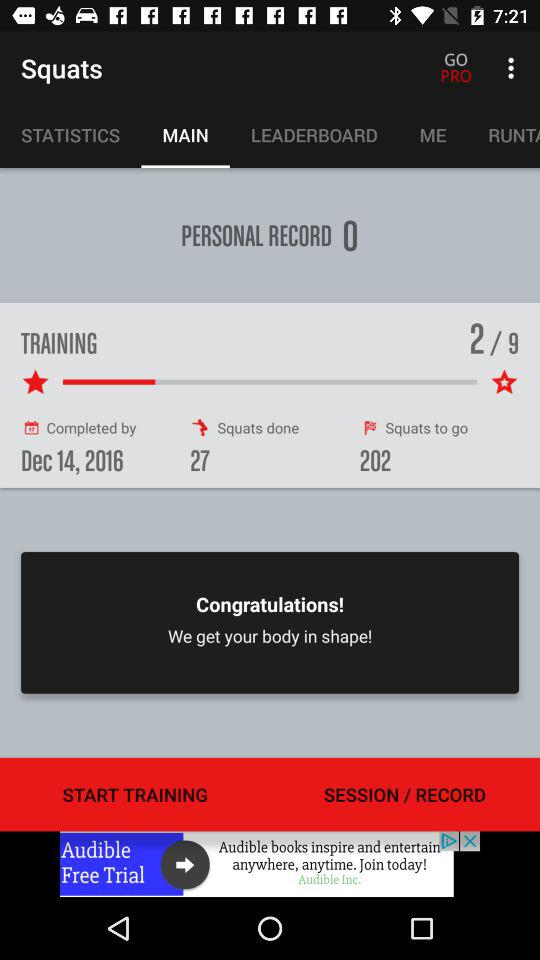By what date does the training have to be completed? The training has to be completed by December 14, 2016. 